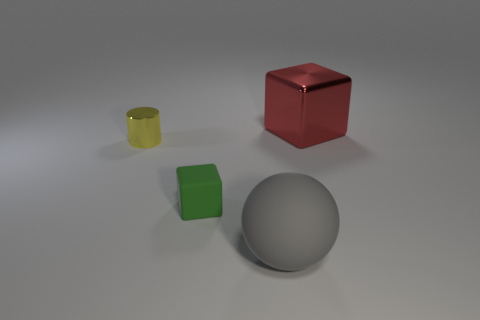Add 3 yellow shiny blocks. How many objects exist? 7 Subtract all balls. How many objects are left? 3 Add 1 gray rubber things. How many gray rubber things are left? 2 Add 2 tiny objects. How many tiny objects exist? 4 Subtract 0 cyan spheres. How many objects are left? 4 Subtract all green rubber blocks. Subtract all tiny purple metal objects. How many objects are left? 3 